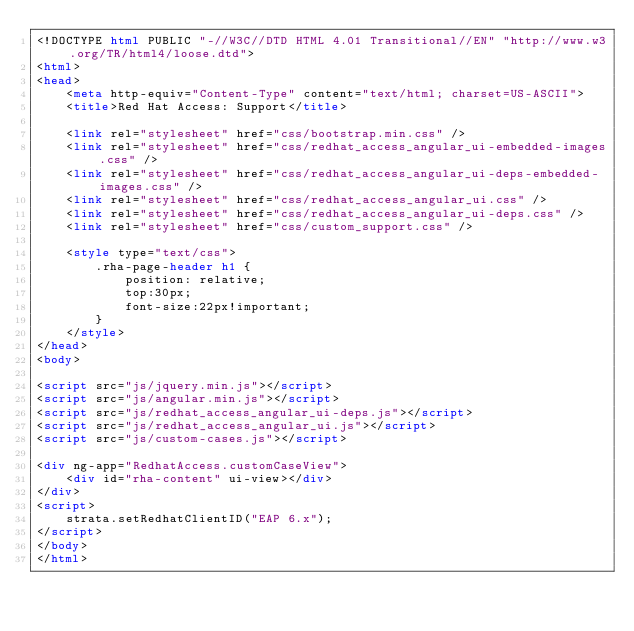<code> <loc_0><loc_0><loc_500><loc_500><_HTML_><!DOCTYPE html PUBLIC "-//W3C//DTD HTML 4.01 Transitional//EN" "http://www.w3.org/TR/html4/loose.dtd">
<html>
<head>
    <meta http-equiv="Content-Type" content="text/html; charset=US-ASCII">
    <title>Red Hat Access: Support</title>

    <link rel="stylesheet" href="css/bootstrap.min.css" />
    <link rel="stylesheet" href="css/redhat_access_angular_ui-embedded-images.css" />
    <link rel="stylesheet" href="css/redhat_access_angular_ui-deps-embedded-images.css" />
    <link rel="stylesheet" href="css/redhat_access_angular_ui.css" />
    <link rel="stylesheet" href="css/redhat_access_angular_ui-deps.css" />
    <link rel="stylesheet" href="css/custom_support.css" />

    <style type="text/css">
        .rha-page-header h1 {
            position: relative;
            top:30px;
            font-size:22px!important;
        }
    </style>
</head>
<body>

<script src="js/jquery.min.js"></script>
<script src="js/angular.min.js"></script>
<script src="js/redhat_access_angular_ui-deps.js"></script>
<script src="js/redhat_access_angular_ui.js"></script>
<script src="js/custom-cases.js"></script>

<div ng-app="RedhatAccess.customCaseView">
    <div id="rha-content" ui-view></div>
</div>
<script>
    strata.setRedhatClientID("EAP 6.x");
</script>
</body>
</html></code> 